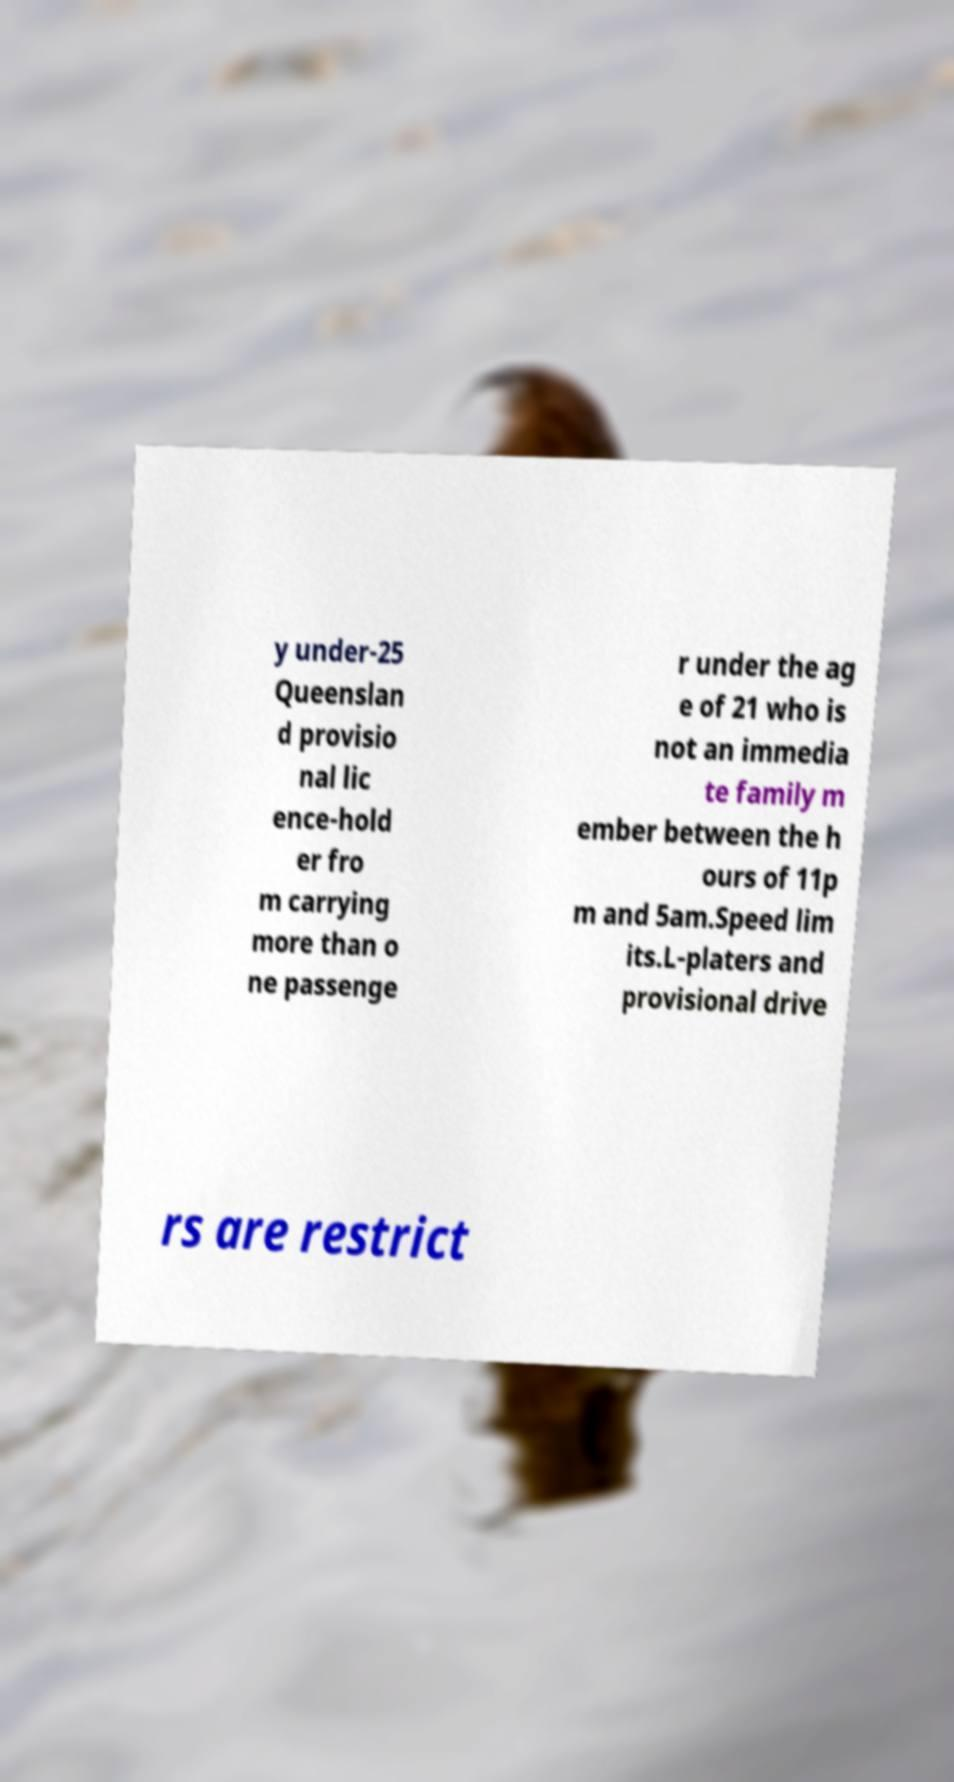For documentation purposes, I need the text within this image transcribed. Could you provide that? y under-25 Queenslan d provisio nal lic ence-hold er fro m carrying more than o ne passenge r under the ag e of 21 who is not an immedia te family m ember between the h ours of 11p m and 5am.Speed lim its.L-platers and provisional drive rs are restrict 